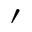<formula> <loc_0><loc_0><loc_500><loc_500>^ { \prime }</formula> 